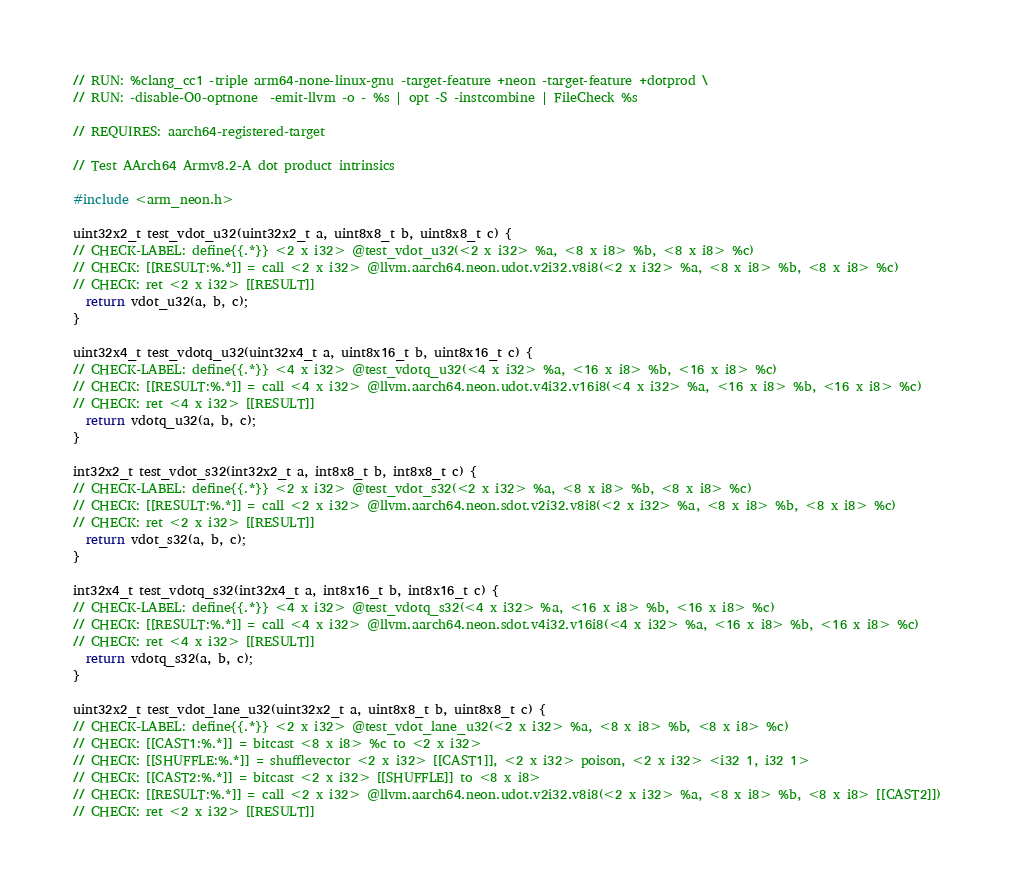<code> <loc_0><loc_0><loc_500><loc_500><_C_>// RUN: %clang_cc1 -triple arm64-none-linux-gnu -target-feature +neon -target-feature +dotprod \
// RUN: -disable-O0-optnone  -emit-llvm -o - %s | opt -S -instcombine | FileCheck %s

// REQUIRES: aarch64-registered-target

// Test AArch64 Armv8.2-A dot product intrinsics

#include <arm_neon.h>

uint32x2_t test_vdot_u32(uint32x2_t a, uint8x8_t b, uint8x8_t c) {
// CHECK-LABEL: define{{.*}} <2 x i32> @test_vdot_u32(<2 x i32> %a, <8 x i8> %b, <8 x i8> %c)
// CHECK: [[RESULT:%.*]] = call <2 x i32> @llvm.aarch64.neon.udot.v2i32.v8i8(<2 x i32> %a, <8 x i8> %b, <8 x i8> %c)
// CHECK: ret <2 x i32> [[RESULT]]
  return vdot_u32(a, b, c);
}

uint32x4_t test_vdotq_u32(uint32x4_t a, uint8x16_t b, uint8x16_t c) {
// CHECK-LABEL: define{{.*}} <4 x i32> @test_vdotq_u32(<4 x i32> %a, <16 x i8> %b, <16 x i8> %c)
// CHECK: [[RESULT:%.*]] = call <4 x i32> @llvm.aarch64.neon.udot.v4i32.v16i8(<4 x i32> %a, <16 x i8> %b, <16 x i8> %c)
// CHECK: ret <4 x i32> [[RESULT]]
  return vdotq_u32(a, b, c);
}

int32x2_t test_vdot_s32(int32x2_t a, int8x8_t b, int8x8_t c) {
// CHECK-LABEL: define{{.*}} <2 x i32> @test_vdot_s32(<2 x i32> %a, <8 x i8> %b, <8 x i8> %c)
// CHECK: [[RESULT:%.*]] = call <2 x i32> @llvm.aarch64.neon.sdot.v2i32.v8i8(<2 x i32> %a, <8 x i8> %b, <8 x i8> %c)
// CHECK: ret <2 x i32> [[RESULT]]
  return vdot_s32(a, b, c);
}

int32x4_t test_vdotq_s32(int32x4_t a, int8x16_t b, int8x16_t c) {
// CHECK-LABEL: define{{.*}} <4 x i32> @test_vdotq_s32(<4 x i32> %a, <16 x i8> %b, <16 x i8> %c)
// CHECK: [[RESULT:%.*]] = call <4 x i32> @llvm.aarch64.neon.sdot.v4i32.v16i8(<4 x i32> %a, <16 x i8> %b, <16 x i8> %c)
// CHECK: ret <4 x i32> [[RESULT]]
  return vdotq_s32(a, b, c);
}

uint32x2_t test_vdot_lane_u32(uint32x2_t a, uint8x8_t b, uint8x8_t c) {
// CHECK-LABEL: define{{.*}} <2 x i32> @test_vdot_lane_u32(<2 x i32> %a, <8 x i8> %b, <8 x i8> %c)
// CHECK: [[CAST1:%.*]] = bitcast <8 x i8> %c to <2 x i32>
// CHECK: [[SHUFFLE:%.*]] = shufflevector <2 x i32> [[CAST1]], <2 x i32> poison, <2 x i32> <i32 1, i32 1>
// CHECK: [[CAST2:%.*]] = bitcast <2 x i32> [[SHUFFLE]] to <8 x i8>
// CHECK: [[RESULT:%.*]] = call <2 x i32> @llvm.aarch64.neon.udot.v2i32.v8i8(<2 x i32> %a, <8 x i8> %b, <8 x i8> [[CAST2]])
// CHECK: ret <2 x i32> [[RESULT]]</code> 